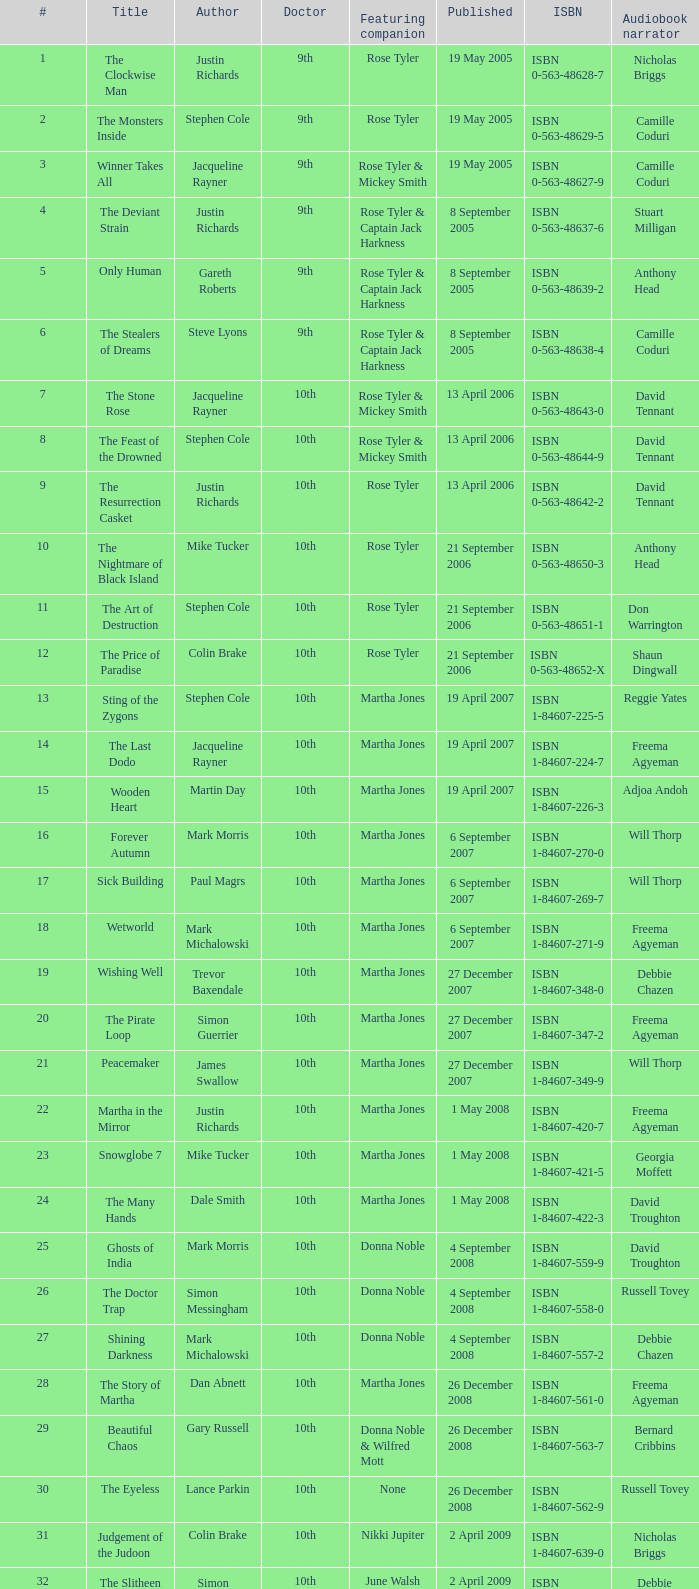What's the title for book number seven? The Stone Rose. 